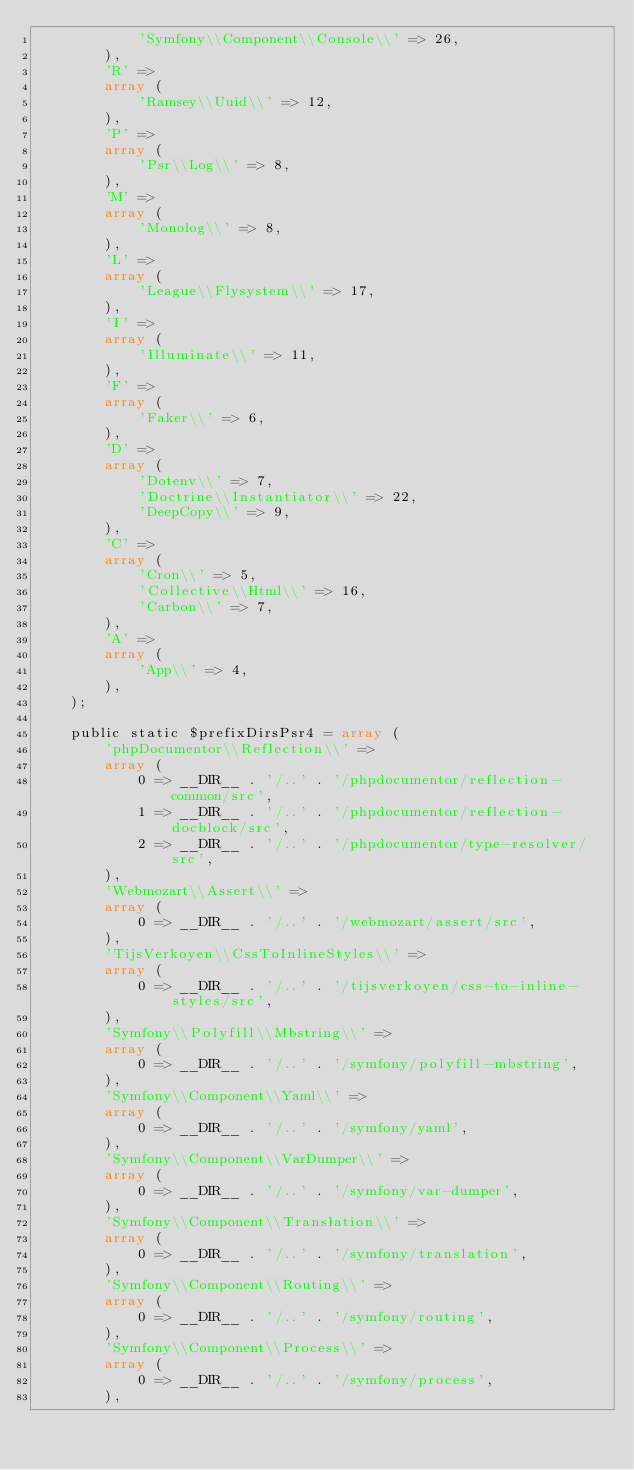<code> <loc_0><loc_0><loc_500><loc_500><_PHP_>            'Symfony\\Component\\Console\\' => 26,
        ),
        'R' => 
        array (
            'Ramsey\\Uuid\\' => 12,
        ),
        'P' => 
        array (
            'Psr\\Log\\' => 8,
        ),
        'M' => 
        array (
            'Monolog\\' => 8,
        ),
        'L' => 
        array (
            'League\\Flysystem\\' => 17,
        ),
        'I' => 
        array (
            'Illuminate\\' => 11,
        ),
        'F' => 
        array (
            'Faker\\' => 6,
        ),
        'D' => 
        array (
            'Dotenv\\' => 7,
            'Doctrine\\Instantiator\\' => 22,
            'DeepCopy\\' => 9,
        ),
        'C' => 
        array (
            'Cron\\' => 5,
            'Collective\\Html\\' => 16,
            'Carbon\\' => 7,
        ),
        'A' => 
        array (
            'App\\' => 4,
        ),
    );

    public static $prefixDirsPsr4 = array (
        'phpDocumentor\\Reflection\\' => 
        array (
            0 => __DIR__ . '/..' . '/phpdocumentor/reflection-common/src',
            1 => __DIR__ . '/..' . '/phpdocumentor/reflection-docblock/src',
            2 => __DIR__ . '/..' . '/phpdocumentor/type-resolver/src',
        ),
        'Webmozart\\Assert\\' => 
        array (
            0 => __DIR__ . '/..' . '/webmozart/assert/src',
        ),
        'TijsVerkoyen\\CssToInlineStyles\\' => 
        array (
            0 => __DIR__ . '/..' . '/tijsverkoyen/css-to-inline-styles/src',
        ),
        'Symfony\\Polyfill\\Mbstring\\' => 
        array (
            0 => __DIR__ . '/..' . '/symfony/polyfill-mbstring',
        ),
        'Symfony\\Component\\Yaml\\' => 
        array (
            0 => __DIR__ . '/..' . '/symfony/yaml',
        ),
        'Symfony\\Component\\VarDumper\\' => 
        array (
            0 => __DIR__ . '/..' . '/symfony/var-dumper',
        ),
        'Symfony\\Component\\Translation\\' => 
        array (
            0 => __DIR__ . '/..' . '/symfony/translation',
        ),
        'Symfony\\Component\\Routing\\' => 
        array (
            0 => __DIR__ . '/..' . '/symfony/routing',
        ),
        'Symfony\\Component\\Process\\' => 
        array (
            0 => __DIR__ . '/..' . '/symfony/process',
        ),</code> 